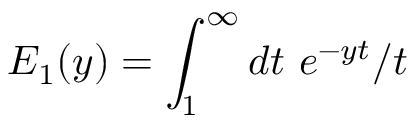Convert formula to latex. <formula><loc_0><loc_0><loc_500><loc_500>E _ { 1 } ( y ) = \int _ { 1 } ^ { \infty } d t \ e ^ { - y t } / t</formula> 